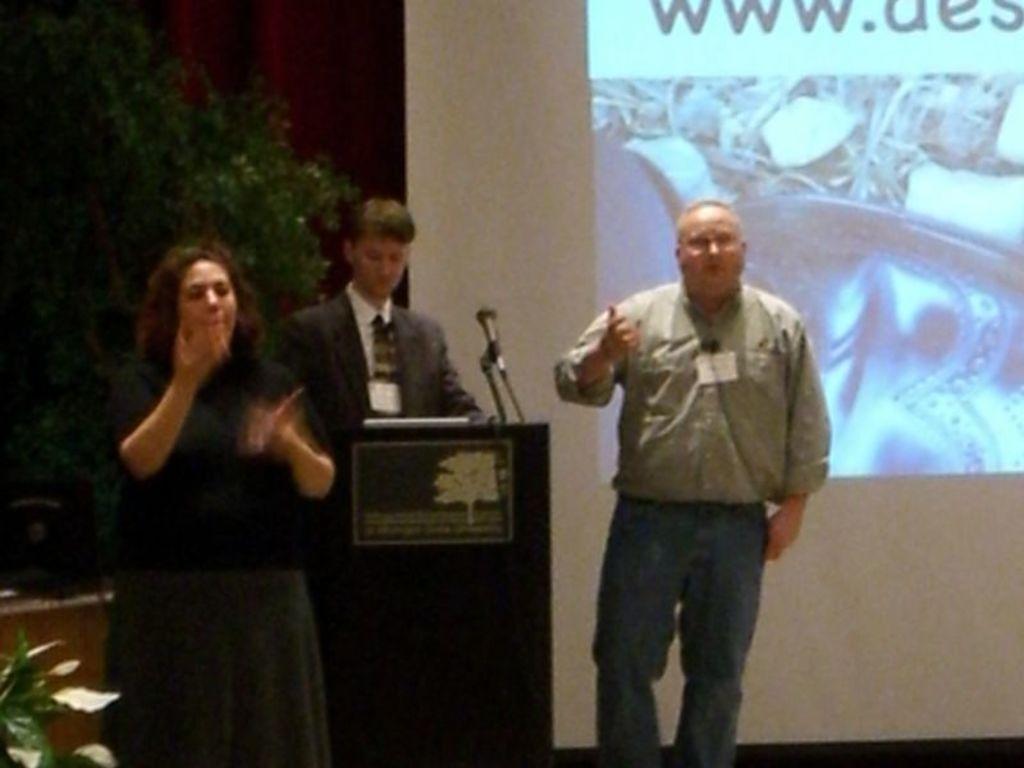How would you summarize this image in a sentence or two? In this image there are two persons standing on the stage, behind them there is another person standing in front of the dais. In the background there is a tree and a screen. 